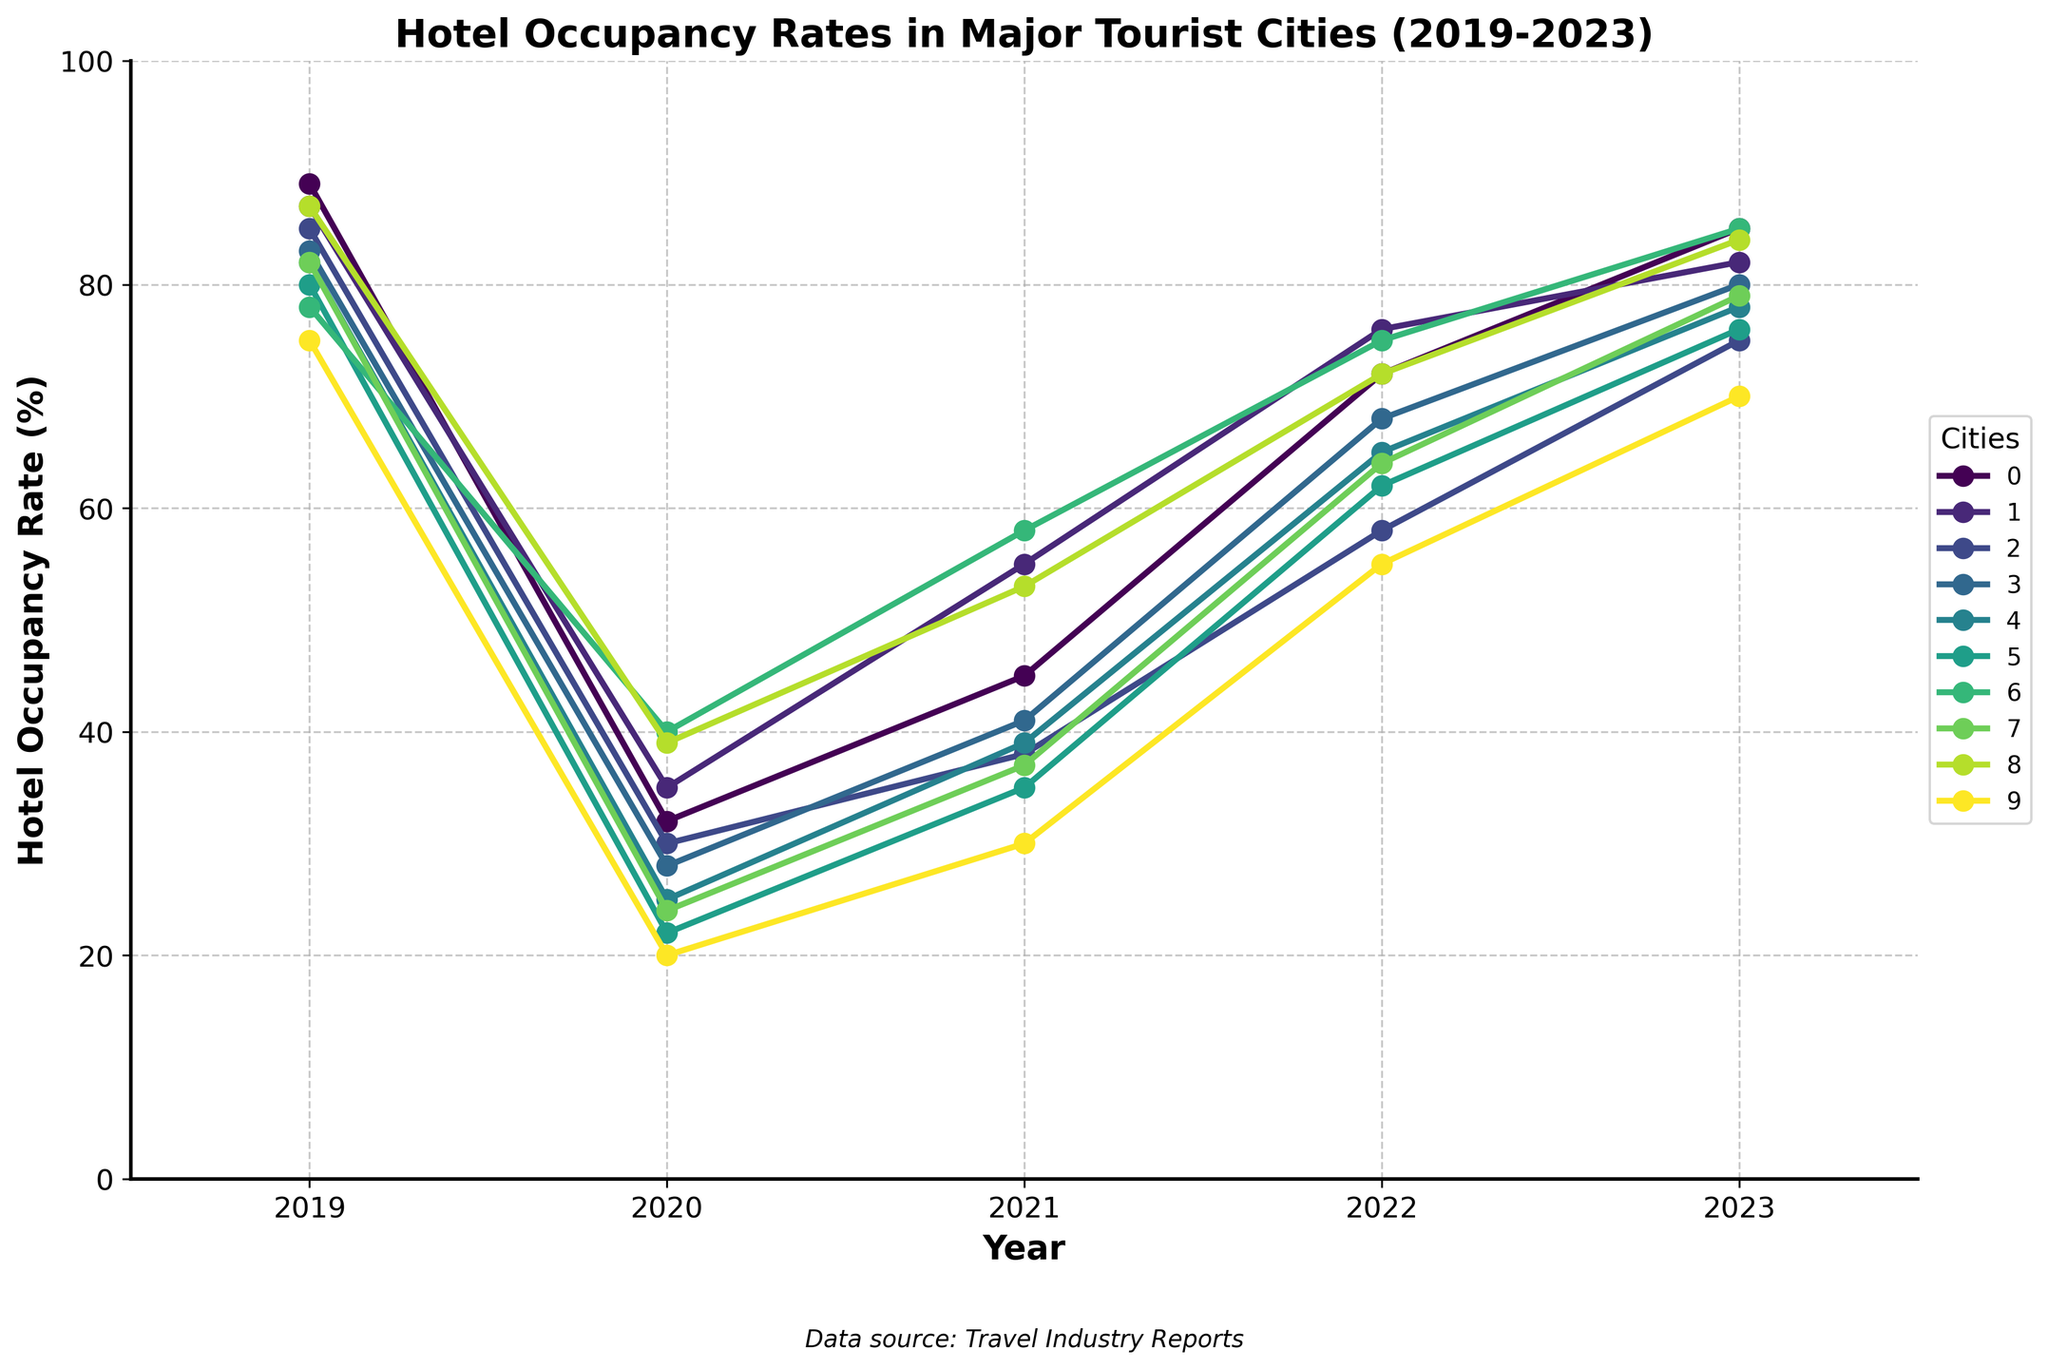Which city had the highest hotel occupancy rate in 2023? Look at the line chart for the year 2023, and find the highest value among all cities. Match the highest value with the city name.
Answer: Paris and Dubai Compare the hotel occupancy rates of Tokyo and Barcelona in 2021. Which city had a higher rate and by how much? Find the values for Tokyo and Barcelona for the year 2021. Tokyo's rate is 38%, and Barcelona's rate is 35%. Calculate the difference: 38% - 35% = 3%.
Answer: Tokyo had a higher rate by 3% What was the average hotel occupancy rate in New York over the years from 2019 to 2023? Sum the occupancy rates for New York for each year and divide by the number of years. (87 + 35 + 55 + 76 + 82) / 5 = 67
Answer: 67 Which year had the lowest average hotel occupancy rate across all cities? Calculate the average rate for each year by summing up the rates for all cities and dividing by the number of cities for each year. Find the year with the lowest average.
Answer: 2020 What is the difference in hotel occupancy rates between 2019 and 2020 in London? Find the occupancy rates for London in 2019 and 2020, and subtract the latter from the former: 83 - 28 = 55.
Answer: 55 Did any city recover to at least 80% occupancy rate by 2023? If yes, name them. Look at the values for the year 2023 and find cities with occupancy rates of 80% or higher.
Answer: Paris, New York, Dubai, Singapore By how much did the hotel occupancy rate in Rome change between 2020 and 2023? Subtract the 2020 rate from the 2023 rate for Rome: 78 - 25 = 53.
Answer: 53 Which city showed the most significant improvement in hotel occupancy rate from 2020 to 2022? Calculate the changes for each city between 2020 and 2022, and identify the city with the highest change:
Answer: Paris with an improvement of 72 - 32 = 40 How many cities had a hotel occupancy rate of less than 60% in 2021? Count the number of cities with values less than 60% for the year 2021.
Answer: 5 In which year did Bangkok have its lowest hotel occupancy rate? Look at the values for Bangkok across all years, and identify the lowest value.
Answer: 2020 